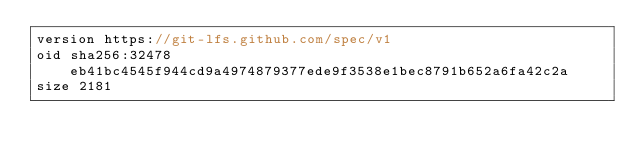<code> <loc_0><loc_0><loc_500><loc_500><_C#_>version https://git-lfs.github.com/spec/v1
oid sha256:32478eb41bc4545f944cd9a4974879377ede9f3538e1bec8791b652a6fa42c2a
size 2181
</code> 